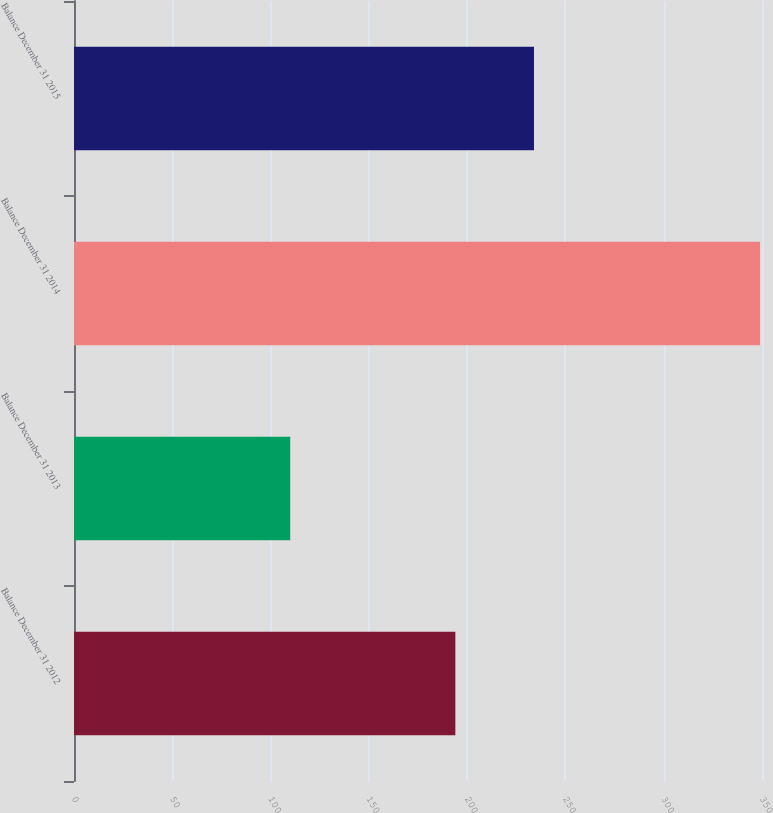<chart> <loc_0><loc_0><loc_500><loc_500><bar_chart><fcel>Balance December 31 2012<fcel>Balance December 31 2013<fcel>Balance December 31 2014<fcel>Balance December 31 2015<nl><fcel>194<fcel>110<fcel>349<fcel>234<nl></chart> 